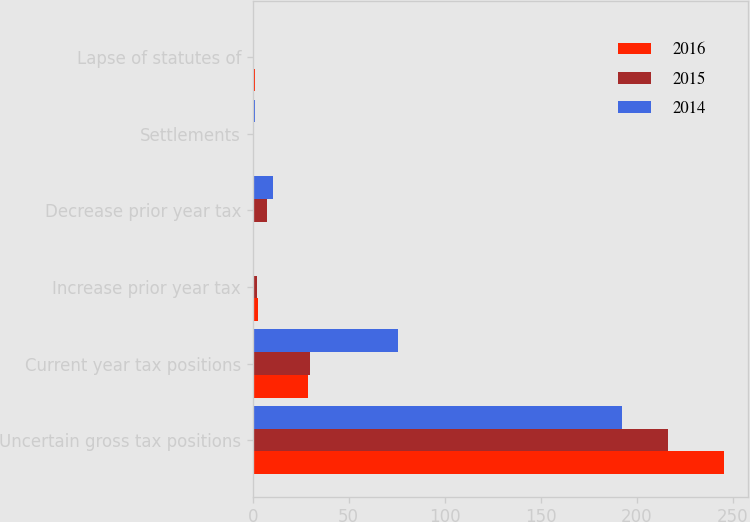Convert chart to OTSL. <chart><loc_0><loc_0><loc_500><loc_500><stacked_bar_chart><ecel><fcel>Uncertain gross tax positions<fcel>Current year tax positions<fcel>Increase prior year tax<fcel>Decrease prior year tax<fcel>Settlements<fcel>Lapse of statutes of<nl><fcel>2016<fcel>245.5<fcel>29<fcel>2.7<fcel>0.9<fcel>0.3<fcel>1.1<nl><fcel>2015<fcel>216.1<fcel>29.6<fcel>2.2<fcel>7.4<fcel>0.4<fcel>0.2<nl><fcel>2014<fcel>192.3<fcel>75.9<fcel>0.6<fcel>10.5<fcel>1<fcel>0.4<nl></chart> 